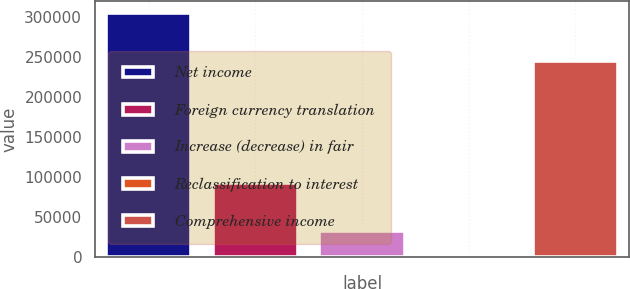<chart> <loc_0><loc_0><loc_500><loc_500><bar_chart><fcel>Net income<fcel>Foreign currency translation<fcel>Increase (decrease) in fair<fcel>Reclassification to interest<fcel>Comprehensive income<nl><fcel>304939<fcel>92312<fcel>32518<fcel>2621<fcel>245145<nl></chart> 